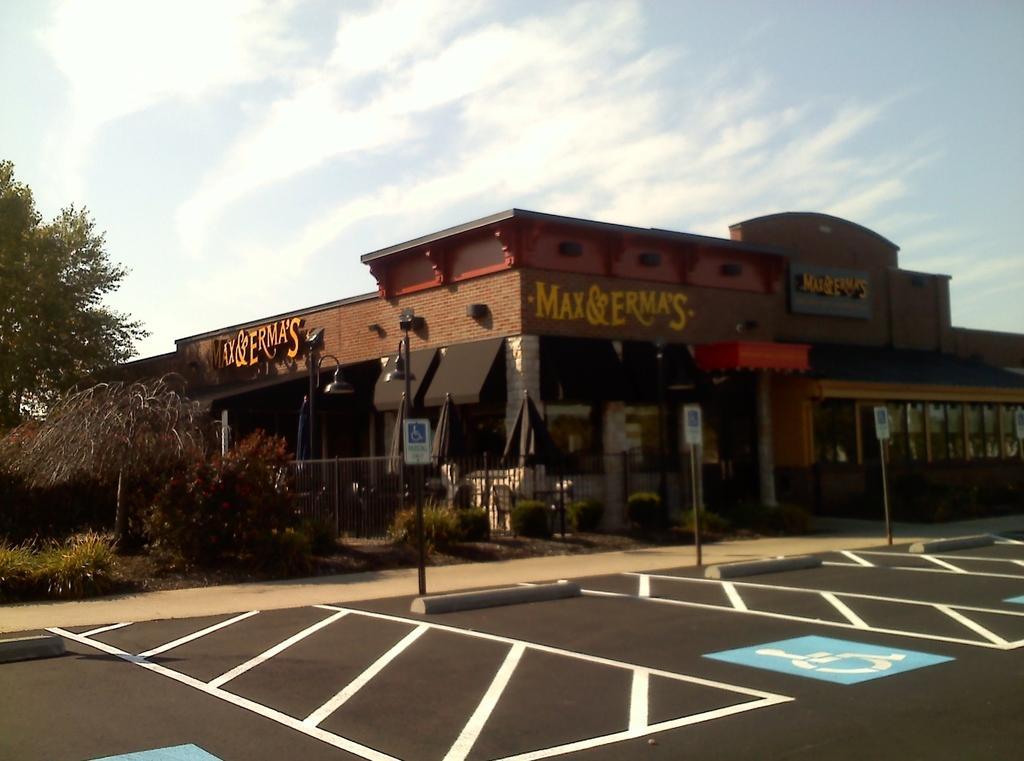In one or two sentences, can you explain what this image depicts? In this image I can see boards, poles, fence, grass, plants, trees, buildings, group of people and the sky. This image is taken may be during a day. 